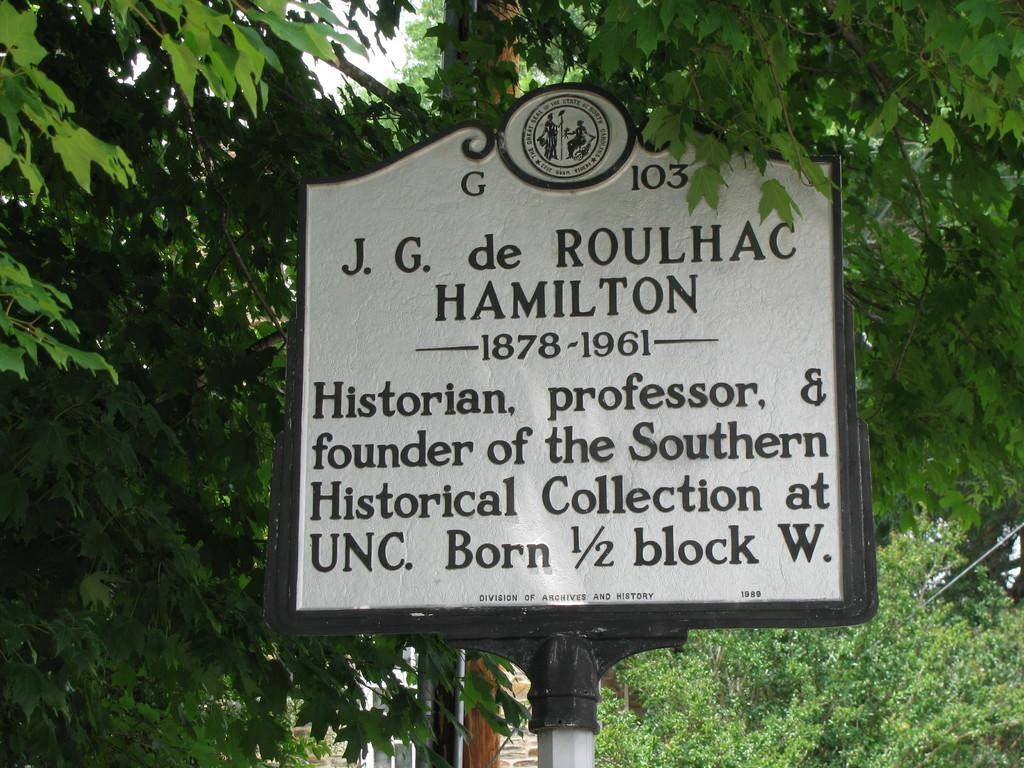What is the main object in the image? There is a name board in the image. What other elements can be seen in the image? There are trees in the image. What can be seen in the background of the image? The sky is visible in the background of the image. What type of dress is the yam wearing in the image? There is no yam or dress present in the image. 